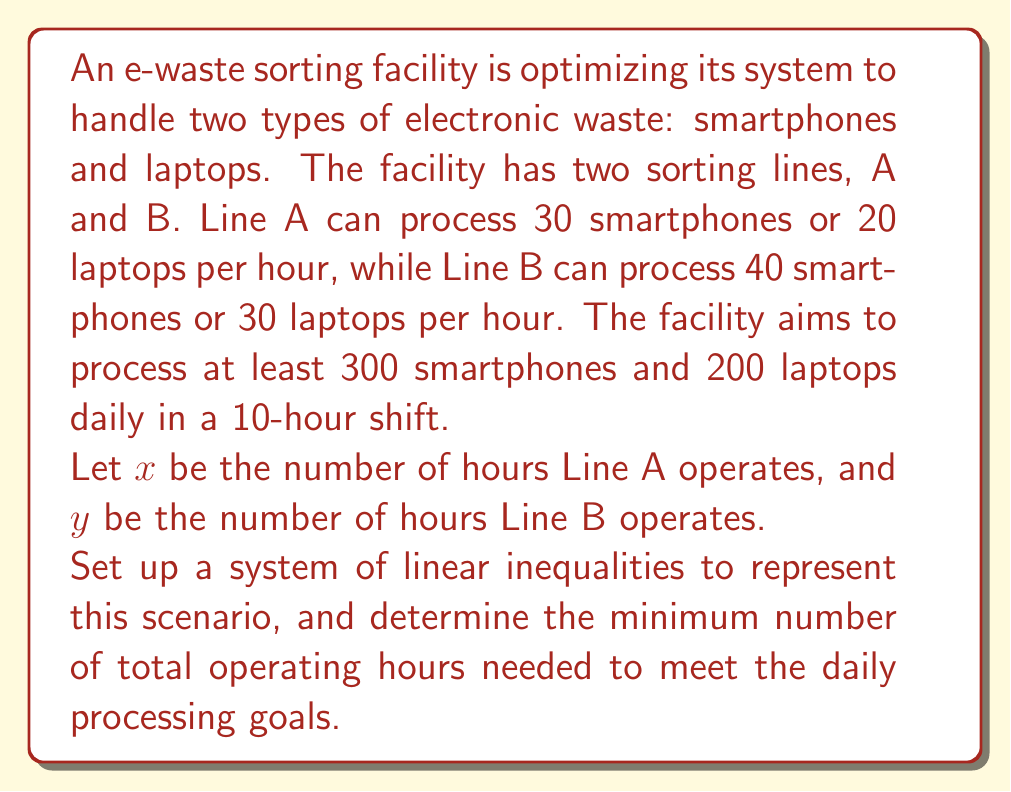What is the answer to this math problem? To solve this problem, we'll follow these steps:

1. Set up the system of linear inequalities
2. Graph the inequalities
3. Identify the feasible region
4. Find the optimal solution

Step 1: Set up the system of linear inequalities

For smartphones:
$$ 30x + 40y \geq 300 $$

For laptops:
$$ 20x + 30y \geq 200 $$

Time constraints:
$$ x \geq 0 $$
$$ y \geq 0 $$
$$ x + y \leq 10 $$

Step 2: Graph the inequalities

[asy]
import graph;
size(200);
xaxis("x", 0, 11, Arrow);
yaxis("y", 0, 11, Arrow);

pen linepen = blue+1;

draw((0,10)--(10,0), linepen);
draw((0,7.5)--(10,2.5), linepen);
draw((0,10)--(10,5), linepen);

label("x + y = 10", (5,5), N);
label("30x + 40y = 300", (5,3.75), SE);
label("20x + 30y = 200", (5,7.5), NW);

fill((0,10)--(3,7)--(5,5)--(2.5,7.5)--cycle, paleblue+opacity(0.2));
[/asy]

Step 3: Identify the feasible region

The feasible region is the area that satisfies all inequalities, shown in light blue in the graph.

Step 4: Find the optimal solution

The optimal solution will be at one of the vertices of the feasible region. We need to find the vertex that minimizes $x + y$. By inspection or by solving the system of equations, we can determine that the optimal point is at the intersection of:

$$ 30x + 40y = 300 $$
$$ 20x + 30y = 200 $$

Solving this system:

$$ 30x + 40y = 300 \quad (1) $$
$$ 20x + 30y = 200 \quad (2) $$

Multiply equation (2) by 3/2:

$$ 30x + 45y = 300 \quad (3) $$

Subtract equation (1) from equation (3):

$$ 5y = 0 $$
$$ y = 0 $$

Substitute $y = 0$ into equation (1):

$$ 30x = 300 $$
$$ x = 10 $$

Therefore, the optimal solution is $x = 10$ and $y = 0$, meaning Line A should operate for 10 hours and Line B for 0 hours.

The minimum total operating hours is $x + y = 10 + 0 = 10$ hours.
Answer: The minimum total operating hours needed to meet the daily processing goals is 10 hours, with Line A operating for 10 hours and Line B not operating. 